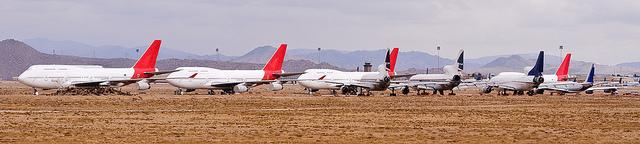What is the main factor keeping the planes on the dirt? landed 